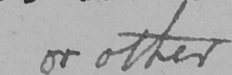Can you tell me what this handwritten text says? or other 